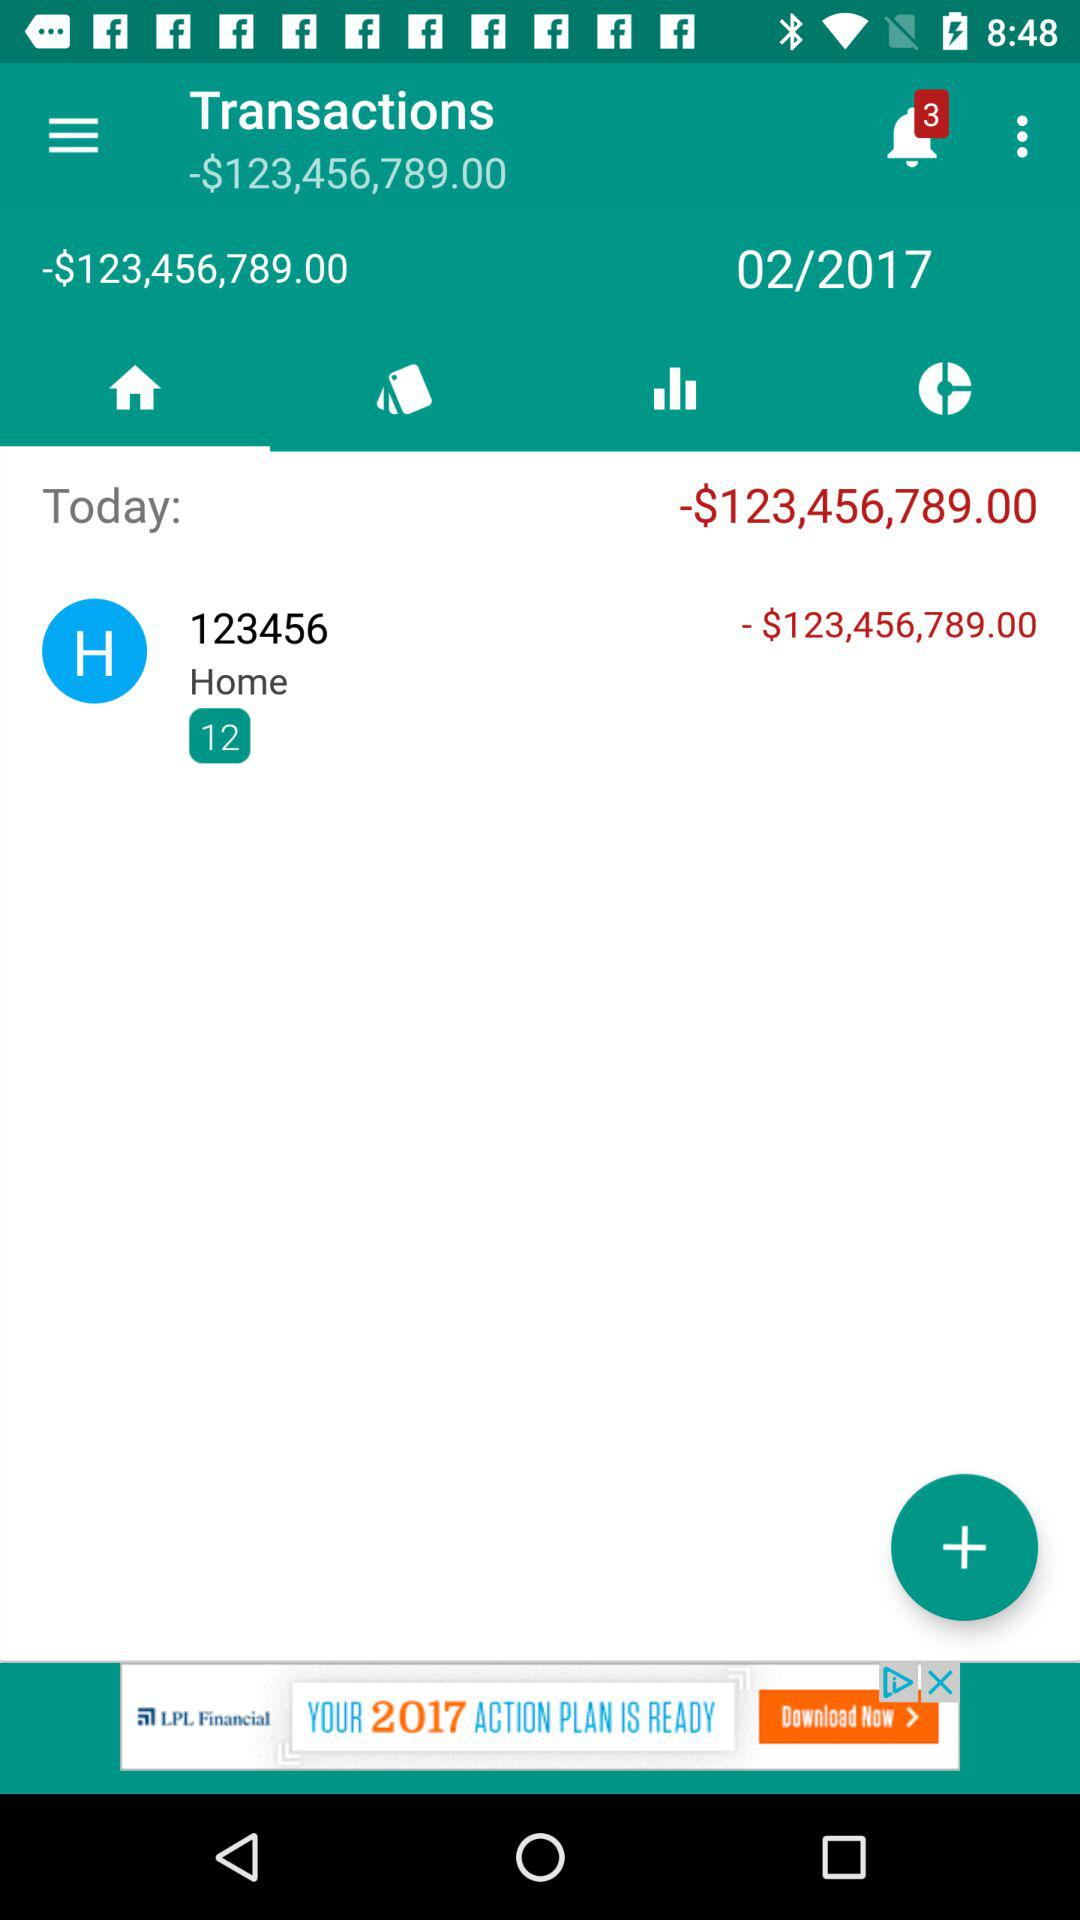What is today's total amount? Today's total amount is "-$123,456,789.00". 